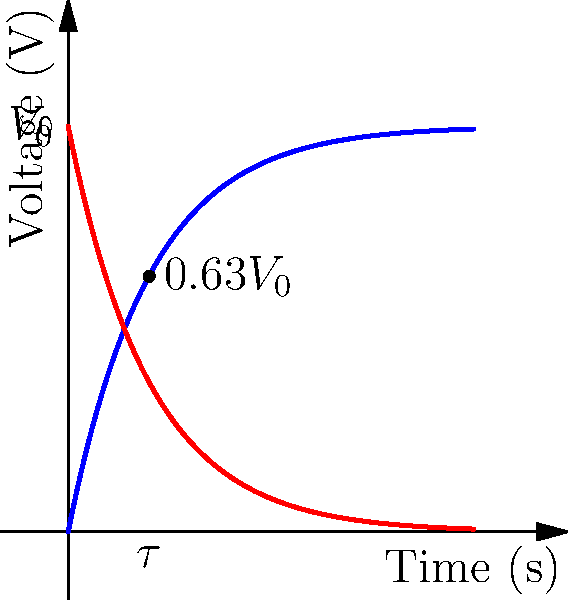In the RC circuit charging and discharging curve graph shown above, what does $\tau$ represent, and what is its significance in relation to the voltage at that point during the charging process? To answer this question, let's break it down step-by-step:

1. $\tau$ represents the time constant of the RC circuit. It is equal to the product of resistance (R) and capacitance (C): $\tau = RC$.

2. The time constant is a measure of how quickly the circuit responds to changes in voltage.

3. During the charging process (blue curve):
   - At $t = 0$, the capacitor voltage is 0.
   - As time increases, the voltage across the capacitor increases exponentially.

4. The significance of $\tau$ during charging:
   - At $t = \tau$, the capacitor has charged to approximately 63.2% of its final voltage.
   - This can be calculated using the equation: $V(t) = V_0(1 - e^{-t/\tau})$
   - When $t = \tau$, $V(\tau) = V_0(1 - e^{-1}) \approx 0.632V_0$

5. This 63.2% point is important because:
   - It provides a standardized way to measure how quickly the capacitor charges.
   - It helps in comparing different RC circuits.
   - It's used to estimate the time needed for full charging (usually considered complete after $5\tau$).

6. The graph clearly shows a dot at the point $(τ, 0.63V_0)$, illustrating this significant moment in the charging process.
Answer: $\tau$ is the time constant, representing the time when the capacitor reaches 63.2% of its final voltage during charging. 